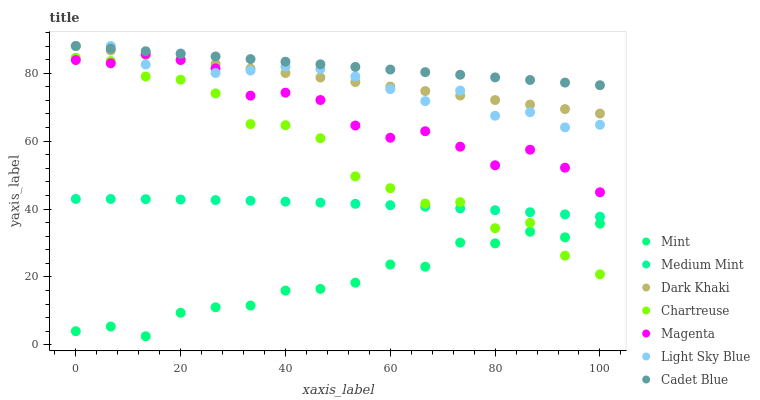Does Mint have the minimum area under the curve?
Answer yes or no. Yes. Does Cadet Blue have the maximum area under the curve?
Answer yes or no. Yes. Does Dark Khaki have the minimum area under the curve?
Answer yes or no. No. Does Dark Khaki have the maximum area under the curve?
Answer yes or no. No. Is Dark Khaki the smoothest?
Answer yes or no. Yes. Is Chartreuse the roughest?
Answer yes or no. Yes. Is Cadet Blue the smoothest?
Answer yes or no. No. Is Cadet Blue the roughest?
Answer yes or no. No. Does Mint have the lowest value?
Answer yes or no. Yes. Does Dark Khaki have the lowest value?
Answer yes or no. No. Does Light Sky Blue have the highest value?
Answer yes or no. Yes. Does Chartreuse have the highest value?
Answer yes or no. No. Is Mint less than Dark Khaki?
Answer yes or no. Yes. Is Dark Khaki greater than Mint?
Answer yes or no. Yes. Does Cadet Blue intersect Light Sky Blue?
Answer yes or no. Yes. Is Cadet Blue less than Light Sky Blue?
Answer yes or no. No. Is Cadet Blue greater than Light Sky Blue?
Answer yes or no. No. Does Mint intersect Dark Khaki?
Answer yes or no. No. 